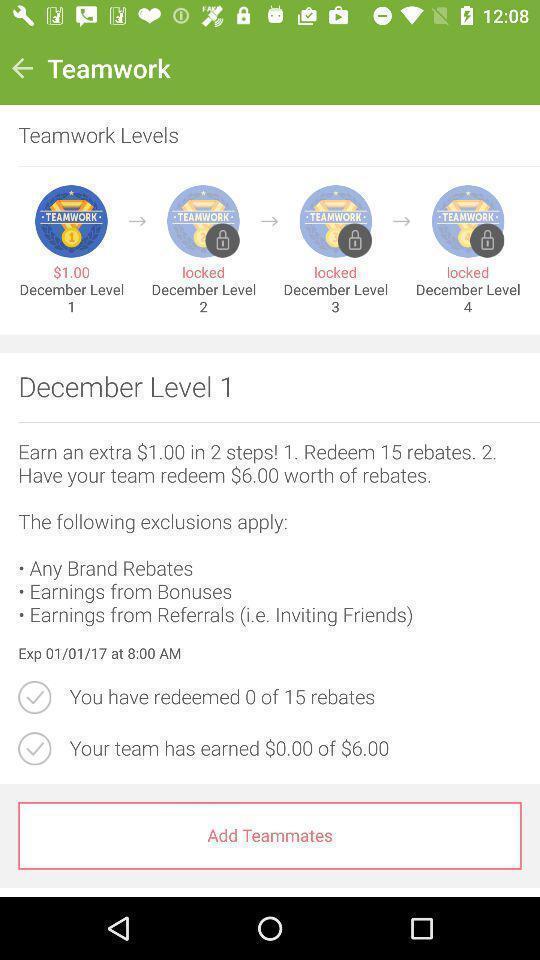What can you discern from this picture? Page displaying options to add teammates. 